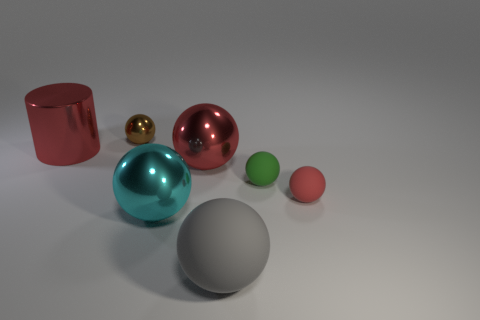What impression does the arrangement of these objects give? The deliberate arrangement of these objects together with their varying sizes, colors, and materials creates a balanced and harmonious composition. It might evoke a sense of deliberate design, perhaps for a study on geometry, reflections, or color theory. Each object is placed with enough space around it to be individually appreciated, yet they form a cohesive group that is pleasing to the eye. 